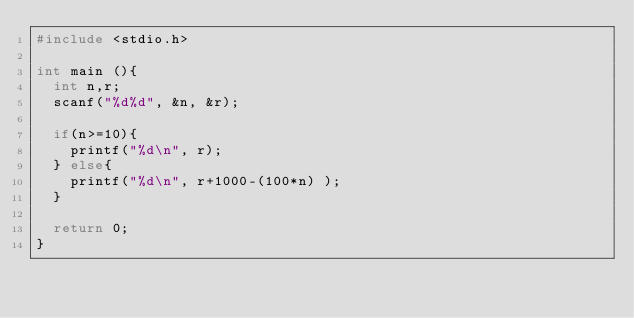<code> <loc_0><loc_0><loc_500><loc_500><_C_>#include <stdio.h>

int main (){
  int n,r;
  scanf("%d%d", &n, &r);

  if(n>=10){
    printf("%d\n", r);
  } else{
    printf("%d\n", r+1000-(100*n) );
  }

  return 0;
}
</code> 